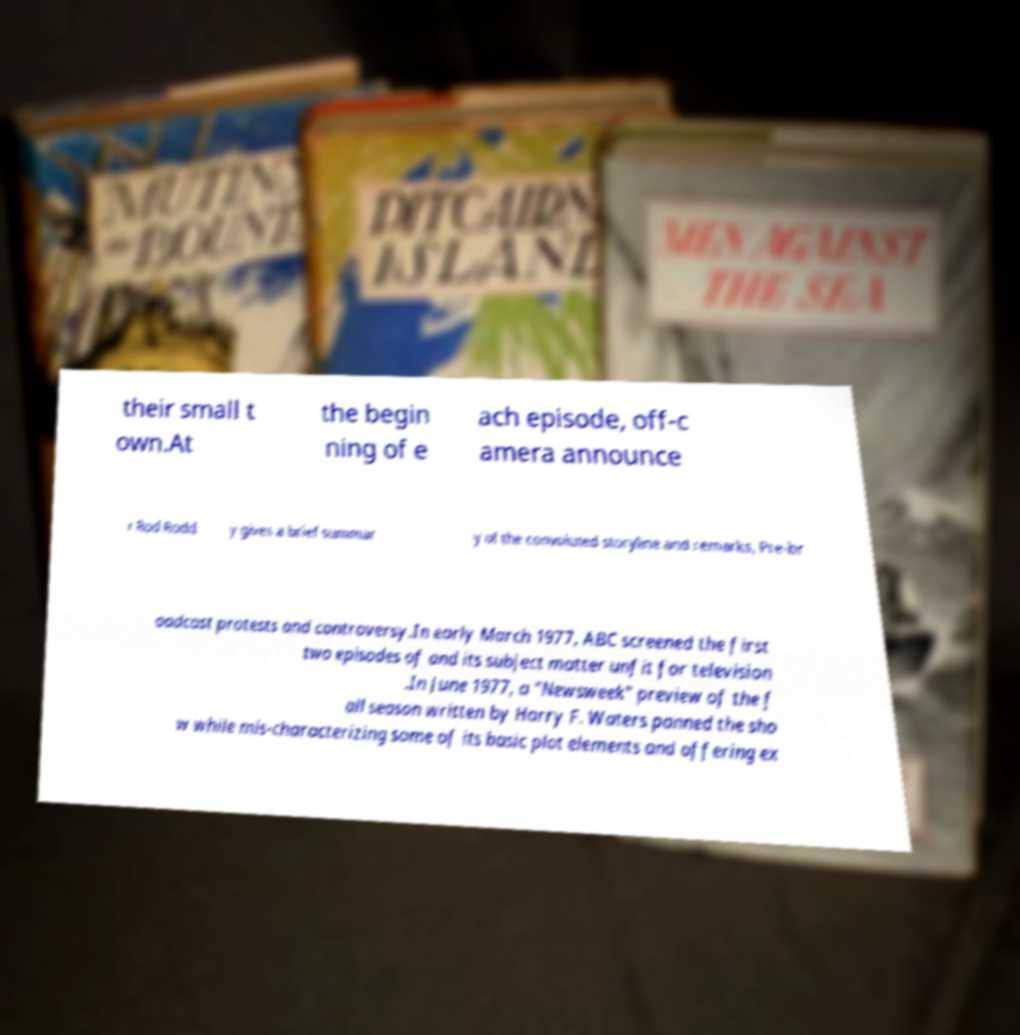Could you extract and type out the text from this image? their small t own.At the begin ning of e ach episode, off-c amera announce r Rod Rodd y gives a brief summar y of the convoluted storyline and remarks, Pre-br oadcast protests and controversy.In early March 1977, ABC screened the first two episodes of and its subject matter unfit for television .In June 1977, a "Newsweek" preview of the f all season written by Harry F. Waters panned the sho w while mis-characterizing some of its basic plot elements and offering ex 